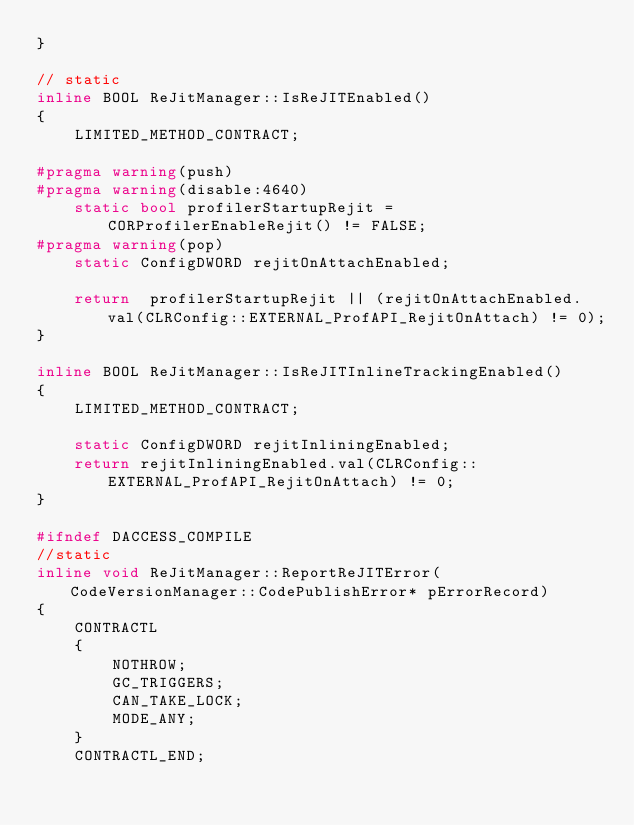Convert code to text. <code><loc_0><loc_0><loc_500><loc_500><_C++_>}

// static
inline BOOL ReJitManager::IsReJITEnabled()
{
    LIMITED_METHOD_CONTRACT;

#pragma warning(push)
#pragma warning(disable:4640)
    static bool profilerStartupRejit = CORProfilerEnableRejit() != FALSE;
#pragma warning(pop)
    static ConfigDWORD rejitOnAttachEnabled;

    return  profilerStartupRejit || (rejitOnAttachEnabled.val(CLRConfig::EXTERNAL_ProfAPI_RejitOnAttach) != 0);
}

inline BOOL ReJitManager::IsReJITInlineTrackingEnabled()
{
    LIMITED_METHOD_CONTRACT;

    static ConfigDWORD rejitInliningEnabled;
    return rejitInliningEnabled.val(CLRConfig::EXTERNAL_ProfAPI_RejitOnAttach) != 0;
}

#ifndef DACCESS_COMPILE
//static
inline void ReJitManager::ReportReJITError(CodeVersionManager::CodePublishError* pErrorRecord)
{
    CONTRACTL
    {
        NOTHROW;
        GC_TRIGGERS;
        CAN_TAKE_LOCK;
        MODE_ANY;
    }
    CONTRACTL_END;</code> 